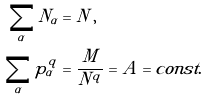<formula> <loc_0><loc_0><loc_500><loc_500>\sum _ { \alpha } N _ { \alpha } & = N \, , \\ \sum _ { \alpha } p _ { \alpha } ^ { q } & = \frac { M } { N ^ { q } } = A = c o n s t .</formula> 